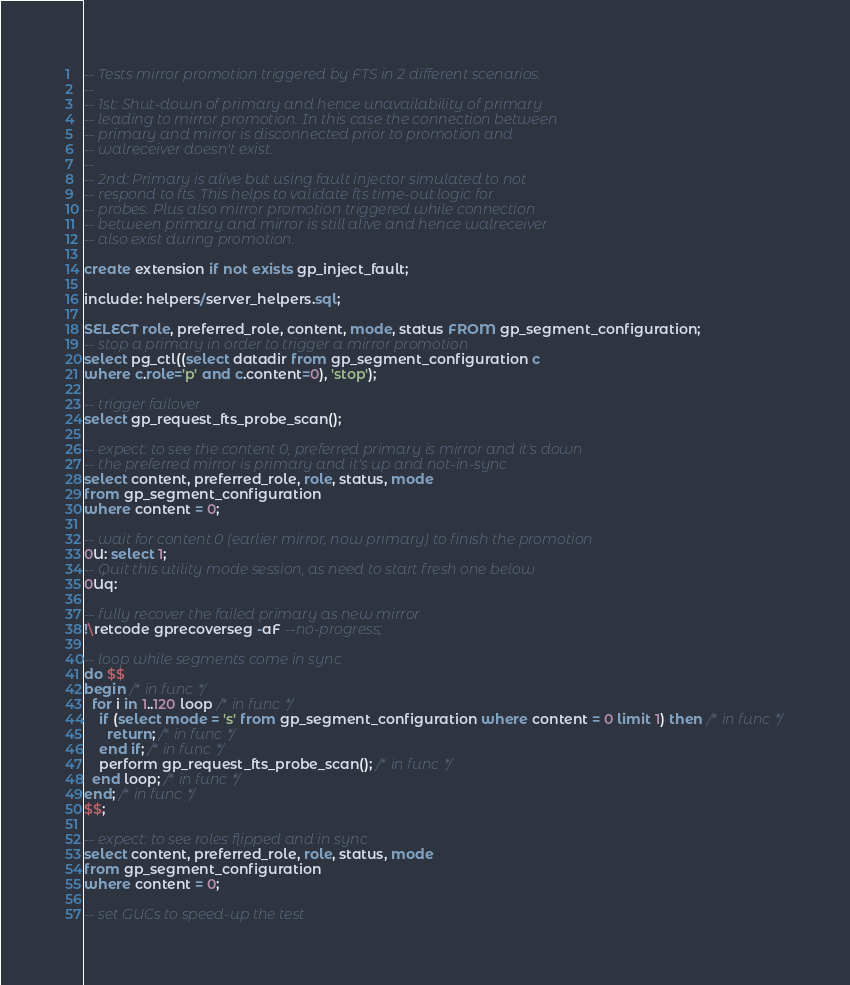Convert code to text. <code><loc_0><loc_0><loc_500><loc_500><_SQL_>-- Tests mirror promotion triggered by FTS in 2 different scenarios.
--
-- 1st: Shut-down of primary and hence unavailability of primary
-- leading to mirror promotion. In this case the connection between
-- primary and mirror is disconnected prior to promotion and
-- walreceiver doesn't exist.
--
-- 2nd: Primary is alive but using fault injector simulated to not
-- respond to fts. This helps to validate fts time-out logic for
-- probes. Plus also mirror promotion triggered while connection
-- between primary and mirror is still alive and hence walreceiver
-- also exist during promotion.

create extension if not exists gp_inject_fault;

include: helpers/server_helpers.sql;

SELECT role, preferred_role, content, mode, status FROM gp_segment_configuration;
-- stop a primary in order to trigger a mirror promotion
select pg_ctl((select datadir from gp_segment_configuration c
where c.role='p' and c.content=0), 'stop');

-- trigger failover
select gp_request_fts_probe_scan();

-- expect: to see the content 0, preferred primary is mirror and it's down
-- the preferred mirror is primary and it's up and not-in-sync
select content, preferred_role, role, status, mode
from gp_segment_configuration
where content = 0;

-- wait for content 0 (earlier mirror, now primary) to finish the promotion
0U: select 1;
-- Quit this utility mode session, as need to start fresh one below
0Uq:

-- fully recover the failed primary as new mirror
!\retcode gprecoverseg -aF --no-progress;

-- loop while segments come in sync
do $$
begin /* in func */
  for i in 1..120 loop /* in func */
    if (select mode = 's' from gp_segment_configuration where content = 0 limit 1) then /* in func */
      return; /* in func */
    end if; /* in func */
    perform gp_request_fts_probe_scan(); /* in func */
  end loop; /* in func */
end; /* in func */
$$;

-- expect: to see roles flipped and in sync
select content, preferred_role, role, status, mode
from gp_segment_configuration
where content = 0;

-- set GUCs to speed-up the test</code> 